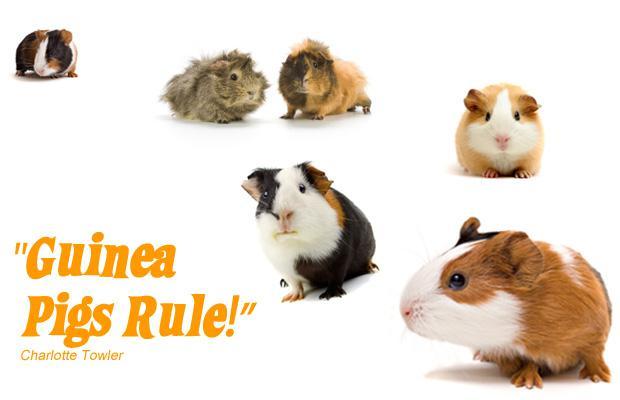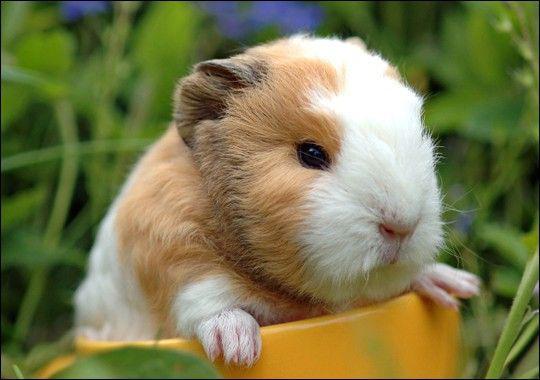The first image is the image on the left, the second image is the image on the right. For the images displayed, is the sentence "Each image shows two side-by-side guinea pigs." factually correct? Answer yes or no. No. The first image is the image on the left, the second image is the image on the right. Examine the images to the left and right. Is the description "The right image contains exactly one rodent." accurate? Answer yes or no. Yes. 